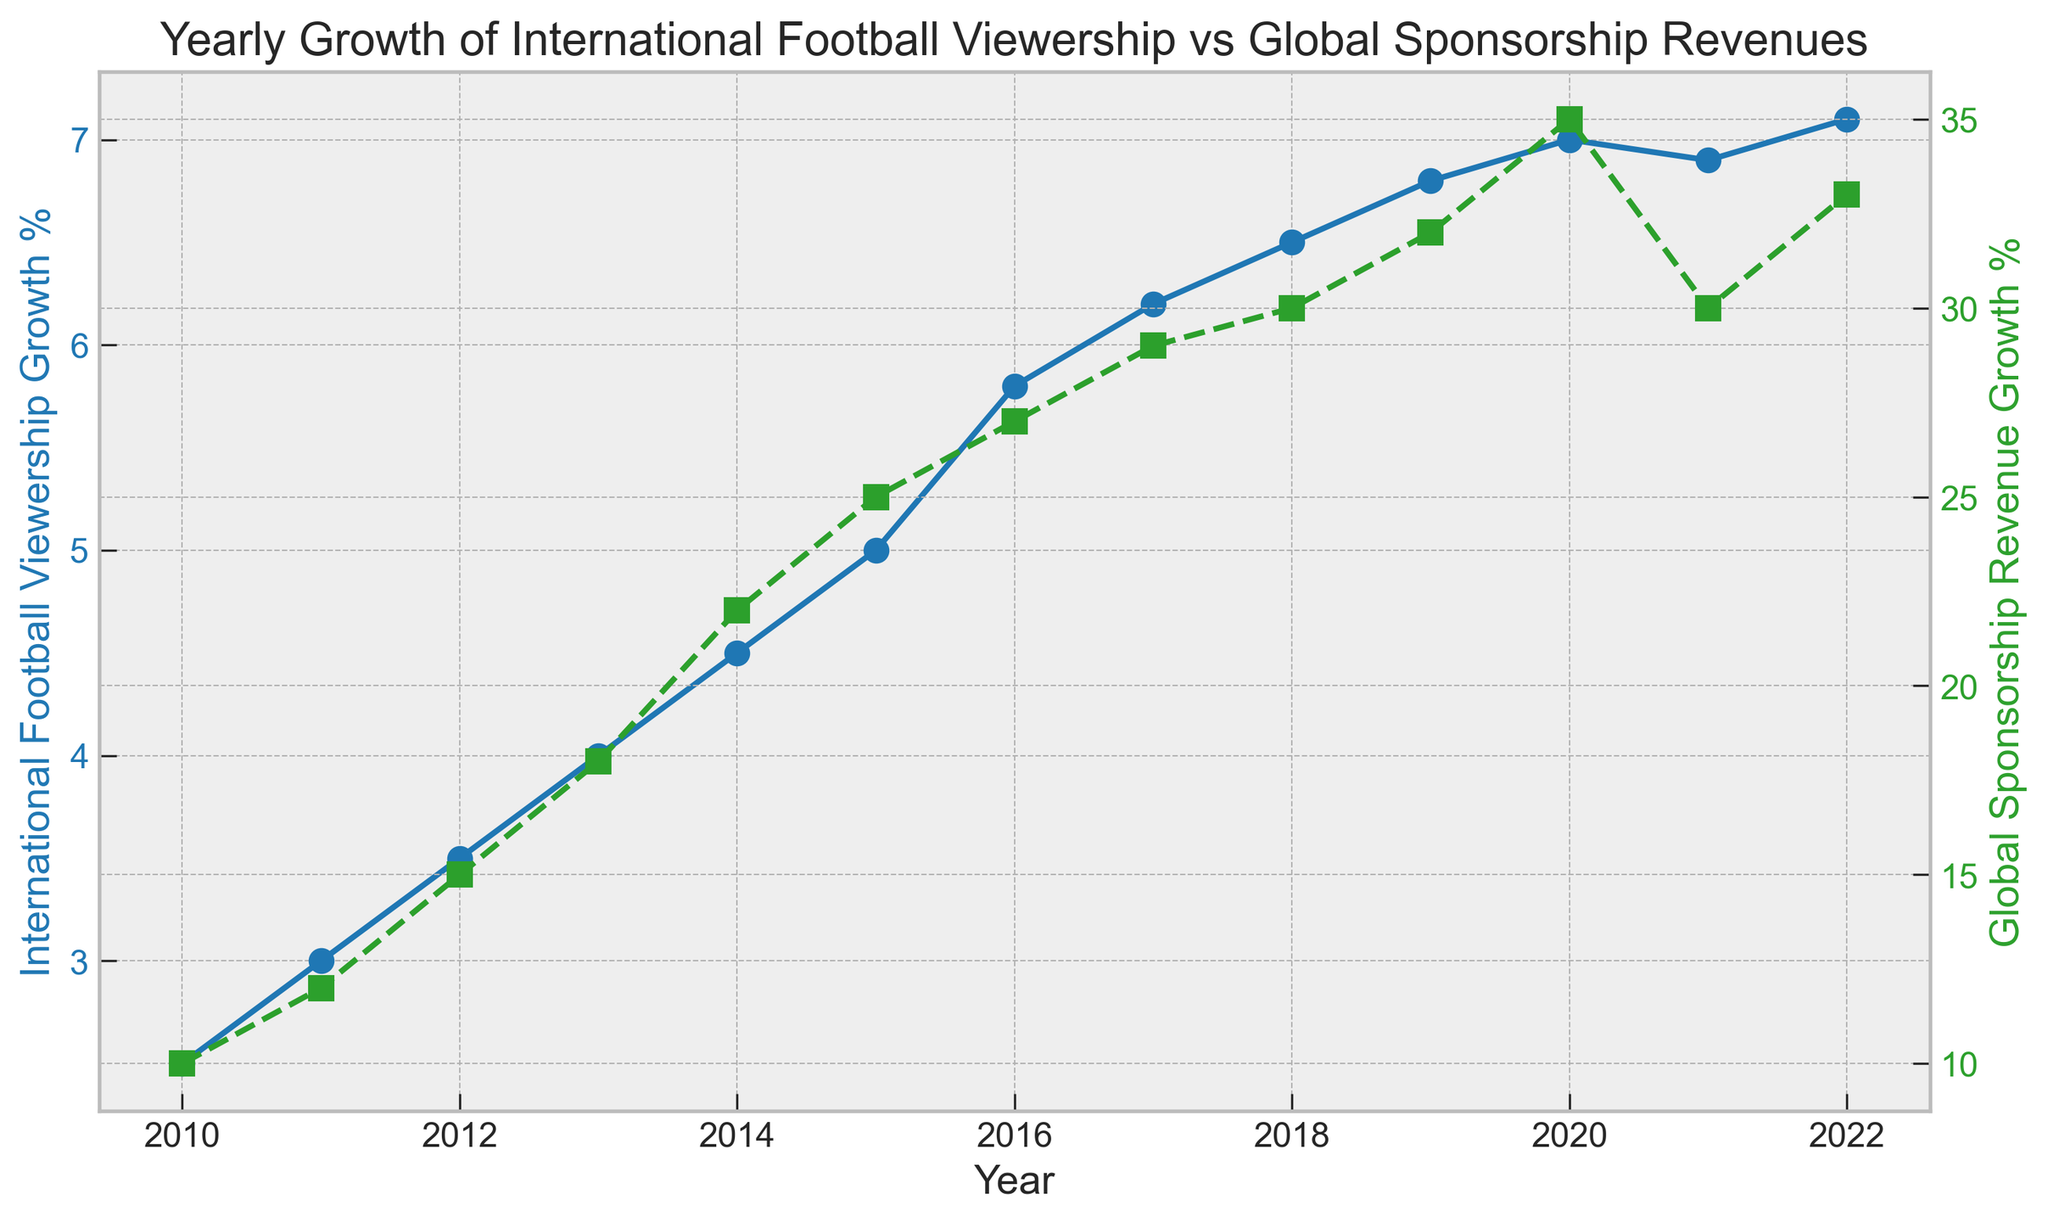What year had the highest International Football Viewership Growth percentage? The blue line representing International Football Viewership Growth % shows the highest point in 2022, indicating the maximum growth.
Answer: 2022 Which year observed a sharper rise in Global Sponsorship Revenue Growth % compared to International Football Viewership Growth %? In 2013, the green line for Global Sponsorship Revenue Growth % has a steep increase from the previous year compared to the blue line for International Football Viewership Growth %.
Answer: 2013 Between 2011 and 2013, by how many percentage points did the Global Sponsorship Revenue Growth % increase? In 2011, the Global Sponsorship Revenue Growth % was 12%, and in 2013, it was 18%. The increase is calculated as 18% - 12% = 6%.
Answer: 6% Compare the growth trends of International Football Viewership and Global Sponsorship Revenue from 2018 to 2020. Which trend is steeper? From 2018 to 2020, the blue line for viewership growth rises from 6.5% to 7.0%, an increase of 0.5 points, while the green line for sponsorship growth rises from 30% to 35%, an increase of 5 points. The green line is steeper.
Answer: Global Sponsorship Revenue What is the difference in the International Football Viewership Growth % between 2010 and 2012? In 2010, the viewership growth was 2.5%, and in 2012, it was 3.5%. The difference is 3.5% - 2.5% = 1%.
Answer: 1% In which year did both the International Football Viewership Growth % and Global Sponsorship Revenue Growth % experience a slight dip? Both metrics experienced a slight dip in 2021 as observed from the declining points on both the blue and green lines.
Answer: 2021 Over the period from 2010 to 2022, what is the average yearly International Football Viewership Growth %? Summing the viewership growth percentages from 2010 to 2022 gives 63.8. Dividing by the number of years (13) gives the average as 63.8 / 13 = 4.9%.
Answer: 4.9% Which year had a higher Global Sponsorship Revenue Growth %, 2014 or 2017? The green line shows the growth in 2014 was 22%, whereas in 2017, it was 29%, making the growth higher in 2017.
Answer: 2017 During which year did International Football Viewership Growth % and Global Sponsorship Revenue Growth % show the same rate of increase? There is no year where both the blue and the green line show the same rate of increase simultaneously.
Answer: None Calculate the total increase in Global Sponsorship Revenue Growth % from 2010 to 2022. The Global Sponsorship Revenue Growth % in 2010 was 10% and in 2022 was 33%. The total increase is 33% - 10% = 23%.
Answer: 23% 